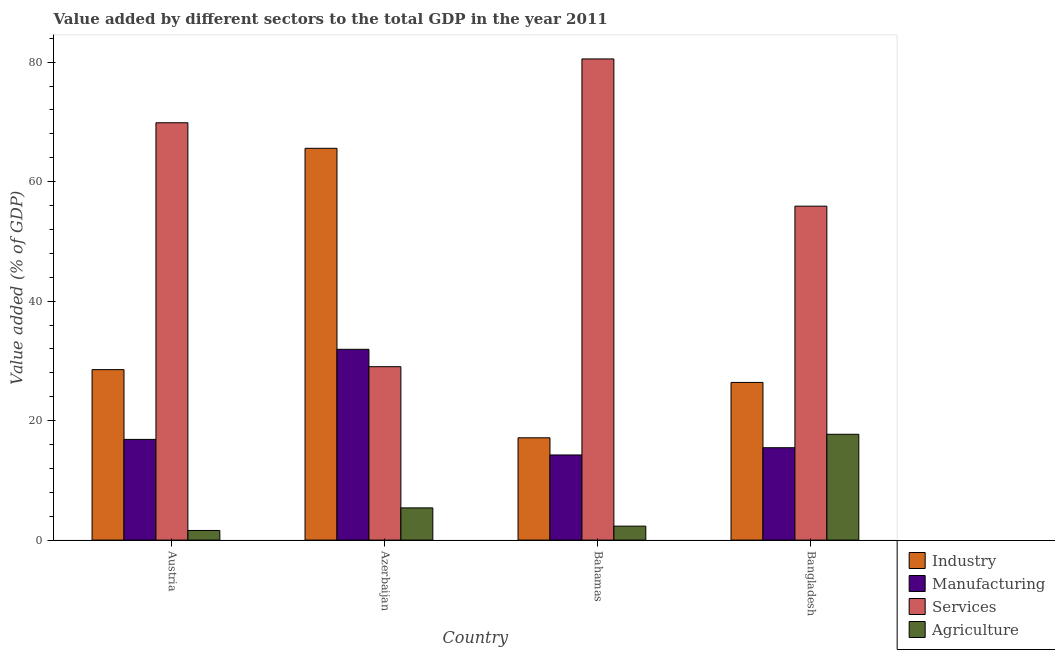How many different coloured bars are there?
Offer a very short reply. 4. How many groups of bars are there?
Provide a succinct answer. 4. Are the number of bars on each tick of the X-axis equal?
Provide a succinct answer. Yes. How many bars are there on the 1st tick from the left?
Your answer should be compact. 4. How many bars are there on the 2nd tick from the right?
Offer a terse response. 4. What is the value added by industrial sector in Austria?
Provide a short and direct response. 28.53. Across all countries, what is the maximum value added by industrial sector?
Give a very brief answer. 65.58. Across all countries, what is the minimum value added by agricultural sector?
Your answer should be very brief. 1.61. In which country was the value added by manufacturing sector maximum?
Your response must be concise. Azerbaijan. What is the total value added by services sector in the graph?
Ensure brevity in your answer.  235.32. What is the difference between the value added by industrial sector in Austria and that in Bangladesh?
Your answer should be very brief. 2.14. What is the difference between the value added by services sector in Azerbaijan and the value added by industrial sector in Austria?
Offer a terse response. 0.49. What is the average value added by industrial sector per country?
Keep it short and to the point. 34.41. What is the difference between the value added by agricultural sector and value added by industrial sector in Austria?
Your response must be concise. -26.92. What is the ratio of the value added by manufacturing sector in Austria to that in Bahamas?
Give a very brief answer. 1.18. Is the value added by agricultural sector in Austria less than that in Azerbaijan?
Your answer should be compact. Yes. Is the difference between the value added by agricultural sector in Bahamas and Bangladesh greater than the difference between the value added by manufacturing sector in Bahamas and Bangladesh?
Your response must be concise. No. What is the difference between the highest and the second highest value added by agricultural sector?
Offer a terse response. 12.32. What is the difference between the highest and the lowest value added by services sector?
Offer a terse response. 51.51. Is the sum of the value added by agricultural sector in Austria and Bangladesh greater than the maximum value added by industrial sector across all countries?
Offer a very short reply. No. Is it the case that in every country, the sum of the value added by industrial sector and value added by services sector is greater than the sum of value added by manufacturing sector and value added by agricultural sector?
Your answer should be very brief. Yes. What does the 1st bar from the left in Bangladesh represents?
Offer a terse response. Industry. What does the 4th bar from the right in Bangladesh represents?
Your answer should be very brief. Industry. How many bars are there?
Make the answer very short. 16. What is the difference between two consecutive major ticks on the Y-axis?
Your answer should be compact. 20. Does the graph contain any zero values?
Ensure brevity in your answer.  No. Does the graph contain grids?
Offer a very short reply. No. Where does the legend appear in the graph?
Give a very brief answer. Bottom right. How many legend labels are there?
Your answer should be very brief. 4. How are the legend labels stacked?
Your response must be concise. Vertical. What is the title of the graph?
Your answer should be compact. Value added by different sectors to the total GDP in the year 2011. What is the label or title of the X-axis?
Provide a short and direct response. Country. What is the label or title of the Y-axis?
Make the answer very short. Value added (% of GDP). What is the Value added (% of GDP) of Industry in Austria?
Your answer should be compact. 28.53. What is the Value added (% of GDP) in Manufacturing in Austria?
Provide a short and direct response. 16.86. What is the Value added (% of GDP) of Services in Austria?
Offer a very short reply. 69.86. What is the Value added (% of GDP) in Agriculture in Austria?
Ensure brevity in your answer.  1.61. What is the Value added (% of GDP) of Industry in Azerbaijan?
Your answer should be compact. 65.58. What is the Value added (% of GDP) of Manufacturing in Azerbaijan?
Give a very brief answer. 31.94. What is the Value added (% of GDP) of Services in Azerbaijan?
Provide a succinct answer. 29.03. What is the Value added (% of GDP) in Agriculture in Azerbaijan?
Offer a very short reply. 5.39. What is the Value added (% of GDP) of Industry in Bahamas?
Provide a succinct answer. 17.12. What is the Value added (% of GDP) in Manufacturing in Bahamas?
Offer a terse response. 14.25. What is the Value added (% of GDP) of Services in Bahamas?
Your answer should be very brief. 80.54. What is the Value added (% of GDP) of Agriculture in Bahamas?
Ensure brevity in your answer.  2.34. What is the Value added (% of GDP) in Industry in Bangladesh?
Give a very brief answer. 26.39. What is the Value added (% of GDP) in Manufacturing in Bangladesh?
Give a very brief answer. 15.46. What is the Value added (% of GDP) in Services in Bangladesh?
Ensure brevity in your answer.  55.9. What is the Value added (% of GDP) in Agriculture in Bangladesh?
Offer a very short reply. 17.71. Across all countries, what is the maximum Value added (% of GDP) of Industry?
Keep it short and to the point. 65.58. Across all countries, what is the maximum Value added (% of GDP) in Manufacturing?
Your response must be concise. 31.94. Across all countries, what is the maximum Value added (% of GDP) of Services?
Give a very brief answer. 80.54. Across all countries, what is the maximum Value added (% of GDP) in Agriculture?
Offer a terse response. 17.71. Across all countries, what is the minimum Value added (% of GDP) in Industry?
Provide a succinct answer. 17.12. Across all countries, what is the minimum Value added (% of GDP) of Manufacturing?
Keep it short and to the point. 14.25. Across all countries, what is the minimum Value added (% of GDP) of Services?
Provide a succinct answer. 29.03. Across all countries, what is the minimum Value added (% of GDP) of Agriculture?
Make the answer very short. 1.61. What is the total Value added (% of GDP) in Industry in the graph?
Give a very brief answer. 137.63. What is the total Value added (% of GDP) of Manufacturing in the graph?
Offer a terse response. 78.51. What is the total Value added (% of GDP) in Services in the graph?
Ensure brevity in your answer.  235.32. What is the total Value added (% of GDP) of Agriculture in the graph?
Give a very brief answer. 27.05. What is the difference between the Value added (% of GDP) in Industry in Austria and that in Azerbaijan?
Keep it short and to the point. -37.05. What is the difference between the Value added (% of GDP) in Manufacturing in Austria and that in Azerbaijan?
Keep it short and to the point. -15.08. What is the difference between the Value added (% of GDP) of Services in Austria and that in Azerbaijan?
Give a very brief answer. 40.83. What is the difference between the Value added (% of GDP) of Agriculture in Austria and that in Azerbaijan?
Keep it short and to the point. -3.78. What is the difference between the Value added (% of GDP) of Industry in Austria and that in Bahamas?
Make the answer very short. 11.41. What is the difference between the Value added (% of GDP) of Manufacturing in Austria and that in Bahamas?
Your response must be concise. 2.61. What is the difference between the Value added (% of GDP) in Services in Austria and that in Bahamas?
Your answer should be compact. -10.68. What is the difference between the Value added (% of GDP) of Agriculture in Austria and that in Bahamas?
Your answer should be compact. -0.73. What is the difference between the Value added (% of GDP) of Industry in Austria and that in Bangladesh?
Offer a terse response. 2.14. What is the difference between the Value added (% of GDP) of Manufacturing in Austria and that in Bangladesh?
Your answer should be very brief. 1.39. What is the difference between the Value added (% of GDP) of Services in Austria and that in Bangladesh?
Your answer should be very brief. 13.96. What is the difference between the Value added (% of GDP) of Agriculture in Austria and that in Bangladesh?
Your response must be concise. -16.1. What is the difference between the Value added (% of GDP) of Industry in Azerbaijan and that in Bahamas?
Your answer should be compact. 48.46. What is the difference between the Value added (% of GDP) in Manufacturing in Azerbaijan and that in Bahamas?
Provide a short and direct response. 17.68. What is the difference between the Value added (% of GDP) in Services in Azerbaijan and that in Bahamas?
Make the answer very short. -51.51. What is the difference between the Value added (% of GDP) of Agriculture in Azerbaijan and that in Bahamas?
Offer a very short reply. 3.06. What is the difference between the Value added (% of GDP) of Industry in Azerbaijan and that in Bangladesh?
Make the answer very short. 39.19. What is the difference between the Value added (% of GDP) of Manufacturing in Azerbaijan and that in Bangladesh?
Your answer should be very brief. 16.47. What is the difference between the Value added (% of GDP) of Services in Azerbaijan and that in Bangladesh?
Keep it short and to the point. -26.87. What is the difference between the Value added (% of GDP) in Agriculture in Azerbaijan and that in Bangladesh?
Your response must be concise. -12.32. What is the difference between the Value added (% of GDP) of Industry in Bahamas and that in Bangladesh?
Make the answer very short. -9.27. What is the difference between the Value added (% of GDP) of Manufacturing in Bahamas and that in Bangladesh?
Ensure brevity in your answer.  -1.21. What is the difference between the Value added (% of GDP) in Services in Bahamas and that in Bangladesh?
Offer a very short reply. 24.64. What is the difference between the Value added (% of GDP) of Agriculture in Bahamas and that in Bangladesh?
Your response must be concise. -15.38. What is the difference between the Value added (% of GDP) in Industry in Austria and the Value added (% of GDP) in Manufacturing in Azerbaijan?
Make the answer very short. -3.4. What is the difference between the Value added (% of GDP) in Industry in Austria and the Value added (% of GDP) in Services in Azerbaijan?
Offer a terse response. -0.49. What is the difference between the Value added (% of GDP) in Industry in Austria and the Value added (% of GDP) in Agriculture in Azerbaijan?
Provide a succinct answer. 23.14. What is the difference between the Value added (% of GDP) in Manufacturing in Austria and the Value added (% of GDP) in Services in Azerbaijan?
Your answer should be very brief. -12.17. What is the difference between the Value added (% of GDP) in Manufacturing in Austria and the Value added (% of GDP) in Agriculture in Azerbaijan?
Provide a succinct answer. 11.46. What is the difference between the Value added (% of GDP) in Services in Austria and the Value added (% of GDP) in Agriculture in Azerbaijan?
Offer a terse response. 64.46. What is the difference between the Value added (% of GDP) of Industry in Austria and the Value added (% of GDP) of Manufacturing in Bahamas?
Make the answer very short. 14.28. What is the difference between the Value added (% of GDP) of Industry in Austria and the Value added (% of GDP) of Services in Bahamas?
Make the answer very short. -52.01. What is the difference between the Value added (% of GDP) in Industry in Austria and the Value added (% of GDP) in Agriculture in Bahamas?
Ensure brevity in your answer.  26.2. What is the difference between the Value added (% of GDP) in Manufacturing in Austria and the Value added (% of GDP) in Services in Bahamas?
Provide a short and direct response. -63.68. What is the difference between the Value added (% of GDP) of Manufacturing in Austria and the Value added (% of GDP) of Agriculture in Bahamas?
Keep it short and to the point. 14.52. What is the difference between the Value added (% of GDP) in Services in Austria and the Value added (% of GDP) in Agriculture in Bahamas?
Offer a very short reply. 67.52. What is the difference between the Value added (% of GDP) in Industry in Austria and the Value added (% of GDP) in Manufacturing in Bangladesh?
Provide a succinct answer. 13.07. What is the difference between the Value added (% of GDP) in Industry in Austria and the Value added (% of GDP) in Services in Bangladesh?
Make the answer very short. -27.36. What is the difference between the Value added (% of GDP) in Industry in Austria and the Value added (% of GDP) in Agriculture in Bangladesh?
Your answer should be compact. 10.82. What is the difference between the Value added (% of GDP) of Manufacturing in Austria and the Value added (% of GDP) of Services in Bangladesh?
Your answer should be very brief. -39.04. What is the difference between the Value added (% of GDP) of Manufacturing in Austria and the Value added (% of GDP) of Agriculture in Bangladesh?
Provide a succinct answer. -0.86. What is the difference between the Value added (% of GDP) in Services in Austria and the Value added (% of GDP) in Agriculture in Bangladesh?
Offer a very short reply. 52.14. What is the difference between the Value added (% of GDP) in Industry in Azerbaijan and the Value added (% of GDP) in Manufacturing in Bahamas?
Offer a terse response. 51.33. What is the difference between the Value added (% of GDP) of Industry in Azerbaijan and the Value added (% of GDP) of Services in Bahamas?
Keep it short and to the point. -14.96. What is the difference between the Value added (% of GDP) in Industry in Azerbaijan and the Value added (% of GDP) in Agriculture in Bahamas?
Ensure brevity in your answer.  63.24. What is the difference between the Value added (% of GDP) of Manufacturing in Azerbaijan and the Value added (% of GDP) of Services in Bahamas?
Make the answer very short. -48.6. What is the difference between the Value added (% of GDP) of Manufacturing in Azerbaijan and the Value added (% of GDP) of Agriculture in Bahamas?
Your answer should be compact. 29.6. What is the difference between the Value added (% of GDP) in Services in Azerbaijan and the Value added (% of GDP) in Agriculture in Bahamas?
Offer a terse response. 26.69. What is the difference between the Value added (% of GDP) of Industry in Azerbaijan and the Value added (% of GDP) of Manufacturing in Bangladesh?
Your answer should be compact. 50.12. What is the difference between the Value added (% of GDP) of Industry in Azerbaijan and the Value added (% of GDP) of Services in Bangladesh?
Provide a succinct answer. 9.69. What is the difference between the Value added (% of GDP) in Industry in Azerbaijan and the Value added (% of GDP) in Agriculture in Bangladesh?
Offer a terse response. 47.87. What is the difference between the Value added (% of GDP) in Manufacturing in Azerbaijan and the Value added (% of GDP) in Services in Bangladesh?
Offer a very short reply. -23.96. What is the difference between the Value added (% of GDP) in Manufacturing in Azerbaijan and the Value added (% of GDP) in Agriculture in Bangladesh?
Ensure brevity in your answer.  14.22. What is the difference between the Value added (% of GDP) of Services in Azerbaijan and the Value added (% of GDP) of Agriculture in Bangladesh?
Give a very brief answer. 11.31. What is the difference between the Value added (% of GDP) in Industry in Bahamas and the Value added (% of GDP) in Manufacturing in Bangladesh?
Make the answer very short. 1.66. What is the difference between the Value added (% of GDP) in Industry in Bahamas and the Value added (% of GDP) in Services in Bangladesh?
Your response must be concise. -38.77. What is the difference between the Value added (% of GDP) of Industry in Bahamas and the Value added (% of GDP) of Agriculture in Bangladesh?
Ensure brevity in your answer.  -0.59. What is the difference between the Value added (% of GDP) of Manufacturing in Bahamas and the Value added (% of GDP) of Services in Bangladesh?
Offer a very short reply. -41.65. What is the difference between the Value added (% of GDP) of Manufacturing in Bahamas and the Value added (% of GDP) of Agriculture in Bangladesh?
Provide a short and direct response. -3.46. What is the difference between the Value added (% of GDP) in Services in Bahamas and the Value added (% of GDP) in Agriculture in Bangladesh?
Ensure brevity in your answer.  62.83. What is the average Value added (% of GDP) of Industry per country?
Offer a very short reply. 34.41. What is the average Value added (% of GDP) of Manufacturing per country?
Provide a succinct answer. 19.63. What is the average Value added (% of GDP) of Services per country?
Give a very brief answer. 58.83. What is the average Value added (% of GDP) in Agriculture per country?
Your answer should be compact. 6.76. What is the difference between the Value added (% of GDP) of Industry and Value added (% of GDP) of Manufacturing in Austria?
Your answer should be very brief. 11.68. What is the difference between the Value added (% of GDP) of Industry and Value added (% of GDP) of Services in Austria?
Your answer should be very brief. -41.32. What is the difference between the Value added (% of GDP) of Industry and Value added (% of GDP) of Agriculture in Austria?
Provide a succinct answer. 26.92. What is the difference between the Value added (% of GDP) in Manufacturing and Value added (% of GDP) in Services in Austria?
Ensure brevity in your answer.  -53. What is the difference between the Value added (% of GDP) in Manufacturing and Value added (% of GDP) in Agriculture in Austria?
Your answer should be very brief. 15.25. What is the difference between the Value added (% of GDP) of Services and Value added (% of GDP) of Agriculture in Austria?
Provide a short and direct response. 68.25. What is the difference between the Value added (% of GDP) in Industry and Value added (% of GDP) in Manufacturing in Azerbaijan?
Provide a succinct answer. 33.65. What is the difference between the Value added (% of GDP) of Industry and Value added (% of GDP) of Services in Azerbaijan?
Your response must be concise. 36.56. What is the difference between the Value added (% of GDP) of Industry and Value added (% of GDP) of Agriculture in Azerbaijan?
Your answer should be compact. 60.19. What is the difference between the Value added (% of GDP) of Manufacturing and Value added (% of GDP) of Services in Azerbaijan?
Offer a very short reply. 2.91. What is the difference between the Value added (% of GDP) in Manufacturing and Value added (% of GDP) in Agriculture in Azerbaijan?
Your response must be concise. 26.54. What is the difference between the Value added (% of GDP) in Services and Value added (% of GDP) in Agriculture in Azerbaijan?
Offer a terse response. 23.63. What is the difference between the Value added (% of GDP) of Industry and Value added (% of GDP) of Manufacturing in Bahamas?
Your response must be concise. 2.87. What is the difference between the Value added (% of GDP) of Industry and Value added (% of GDP) of Services in Bahamas?
Give a very brief answer. -63.42. What is the difference between the Value added (% of GDP) of Industry and Value added (% of GDP) of Agriculture in Bahamas?
Ensure brevity in your answer.  14.79. What is the difference between the Value added (% of GDP) of Manufacturing and Value added (% of GDP) of Services in Bahamas?
Make the answer very short. -66.29. What is the difference between the Value added (% of GDP) in Manufacturing and Value added (% of GDP) in Agriculture in Bahamas?
Provide a succinct answer. 11.91. What is the difference between the Value added (% of GDP) in Services and Value added (% of GDP) in Agriculture in Bahamas?
Your answer should be very brief. 78.2. What is the difference between the Value added (% of GDP) of Industry and Value added (% of GDP) of Manufacturing in Bangladesh?
Your response must be concise. 10.93. What is the difference between the Value added (% of GDP) in Industry and Value added (% of GDP) in Services in Bangladesh?
Your answer should be compact. -29.5. What is the difference between the Value added (% of GDP) of Industry and Value added (% of GDP) of Agriculture in Bangladesh?
Offer a terse response. 8.68. What is the difference between the Value added (% of GDP) in Manufacturing and Value added (% of GDP) in Services in Bangladesh?
Your answer should be very brief. -40.43. What is the difference between the Value added (% of GDP) in Manufacturing and Value added (% of GDP) in Agriculture in Bangladesh?
Give a very brief answer. -2.25. What is the difference between the Value added (% of GDP) of Services and Value added (% of GDP) of Agriculture in Bangladesh?
Your answer should be very brief. 38.18. What is the ratio of the Value added (% of GDP) of Industry in Austria to that in Azerbaijan?
Offer a terse response. 0.44. What is the ratio of the Value added (% of GDP) of Manufacturing in Austria to that in Azerbaijan?
Your answer should be compact. 0.53. What is the ratio of the Value added (% of GDP) in Services in Austria to that in Azerbaijan?
Your response must be concise. 2.41. What is the ratio of the Value added (% of GDP) of Agriculture in Austria to that in Azerbaijan?
Your answer should be compact. 0.3. What is the ratio of the Value added (% of GDP) of Industry in Austria to that in Bahamas?
Your answer should be very brief. 1.67. What is the ratio of the Value added (% of GDP) in Manufacturing in Austria to that in Bahamas?
Provide a short and direct response. 1.18. What is the ratio of the Value added (% of GDP) in Services in Austria to that in Bahamas?
Give a very brief answer. 0.87. What is the ratio of the Value added (% of GDP) of Agriculture in Austria to that in Bahamas?
Your response must be concise. 0.69. What is the ratio of the Value added (% of GDP) of Industry in Austria to that in Bangladesh?
Your response must be concise. 1.08. What is the ratio of the Value added (% of GDP) of Manufacturing in Austria to that in Bangladesh?
Ensure brevity in your answer.  1.09. What is the ratio of the Value added (% of GDP) in Services in Austria to that in Bangladesh?
Offer a very short reply. 1.25. What is the ratio of the Value added (% of GDP) in Agriculture in Austria to that in Bangladesh?
Your answer should be compact. 0.09. What is the ratio of the Value added (% of GDP) in Industry in Azerbaijan to that in Bahamas?
Your answer should be very brief. 3.83. What is the ratio of the Value added (% of GDP) of Manufacturing in Azerbaijan to that in Bahamas?
Give a very brief answer. 2.24. What is the ratio of the Value added (% of GDP) of Services in Azerbaijan to that in Bahamas?
Provide a succinct answer. 0.36. What is the ratio of the Value added (% of GDP) in Agriculture in Azerbaijan to that in Bahamas?
Make the answer very short. 2.31. What is the ratio of the Value added (% of GDP) of Industry in Azerbaijan to that in Bangladesh?
Your answer should be very brief. 2.48. What is the ratio of the Value added (% of GDP) in Manufacturing in Azerbaijan to that in Bangladesh?
Make the answer very short. 2.07. What is the ratio of the Value added (% of GDP) in Services in Azerbaijan to that in Bangladesh?
Give a very brief answer. 0.52. What is the ratio of the Value added (% of GDP) in Agriculture in Azerbaijan to that in Bangladesh?
Make the answer very short. 0.3. What is the ratio of the Value added (% of GDP) of Industry in Bahamas to that in Bangladesh?
Provide a short and direct response. 0.65. What is the ratio of the Value added (% of GDP) of Manufacturing in Bahamas to that in Bangladesh?
Give a very brief answer. 0.92. What is the ratio of the Value added (% of GDP) of Services in Bahamas to that in Bangladesh?
Keep it short and to the point. 1.44. What is the ratio of the Value added (% of GDP) of Agriculture in Bahamas to that in Bangladesh?
Your response must be concise. 0.13. What is the difference between the highest and the second highest Value added (% of GDP) of Industry?
Your answer should be very brief. 37.05. What is the difference between the highest and the second highest Value added (% of GDP) in Manufacturing?
Keep it short and to the point. 15.08. What is the difference between the highest and the second highest Value added (% of GDP) of Services?
Give a very brief answer. 10.68. What is the difference between the highest and the second highest Value added (% of GDP) in Agriculture?
Provide a short and direct response. 12.32. What is the difference between the highest and the lowest Value added (% of GDP) in Industry?
Make the answer very short. 48.46. What is the difference between the highest and the lowest Value added (% of GDP) of Manufacturing?
Give a very brief answer. 17.68. What is the difference between the highest and the lowest Value added (% of GDP) of Services?
Your answer should be very brief. 51.51. What is the difference between the highest and the lowest Value added (% of GDP) in Agriculture?
Give a very brief answer. 16.1. 